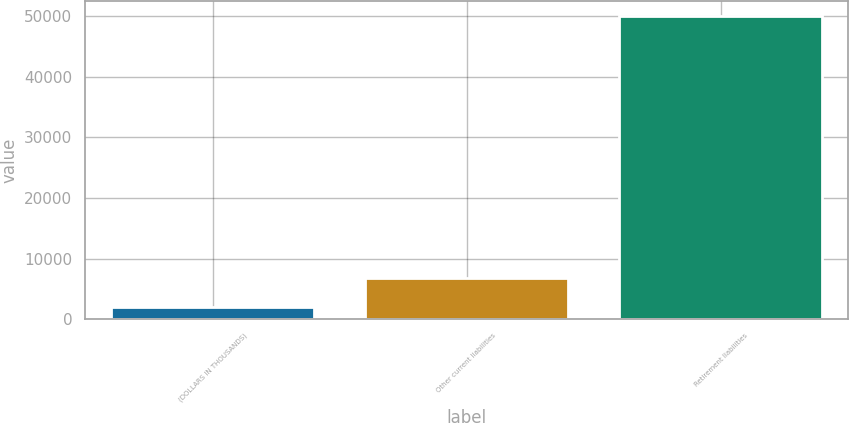Convert chart to OTSL. <chart><loc_0><loc_0><loc_500><loc_500><bar_chart><fcel>(DOLLARS IN THOUSANDS)<fcel>Other current liabilities<fcel>Retirement liabilities<nl><fcel>2017<fcel>6813.4<fcel>49981<nl></chart> 